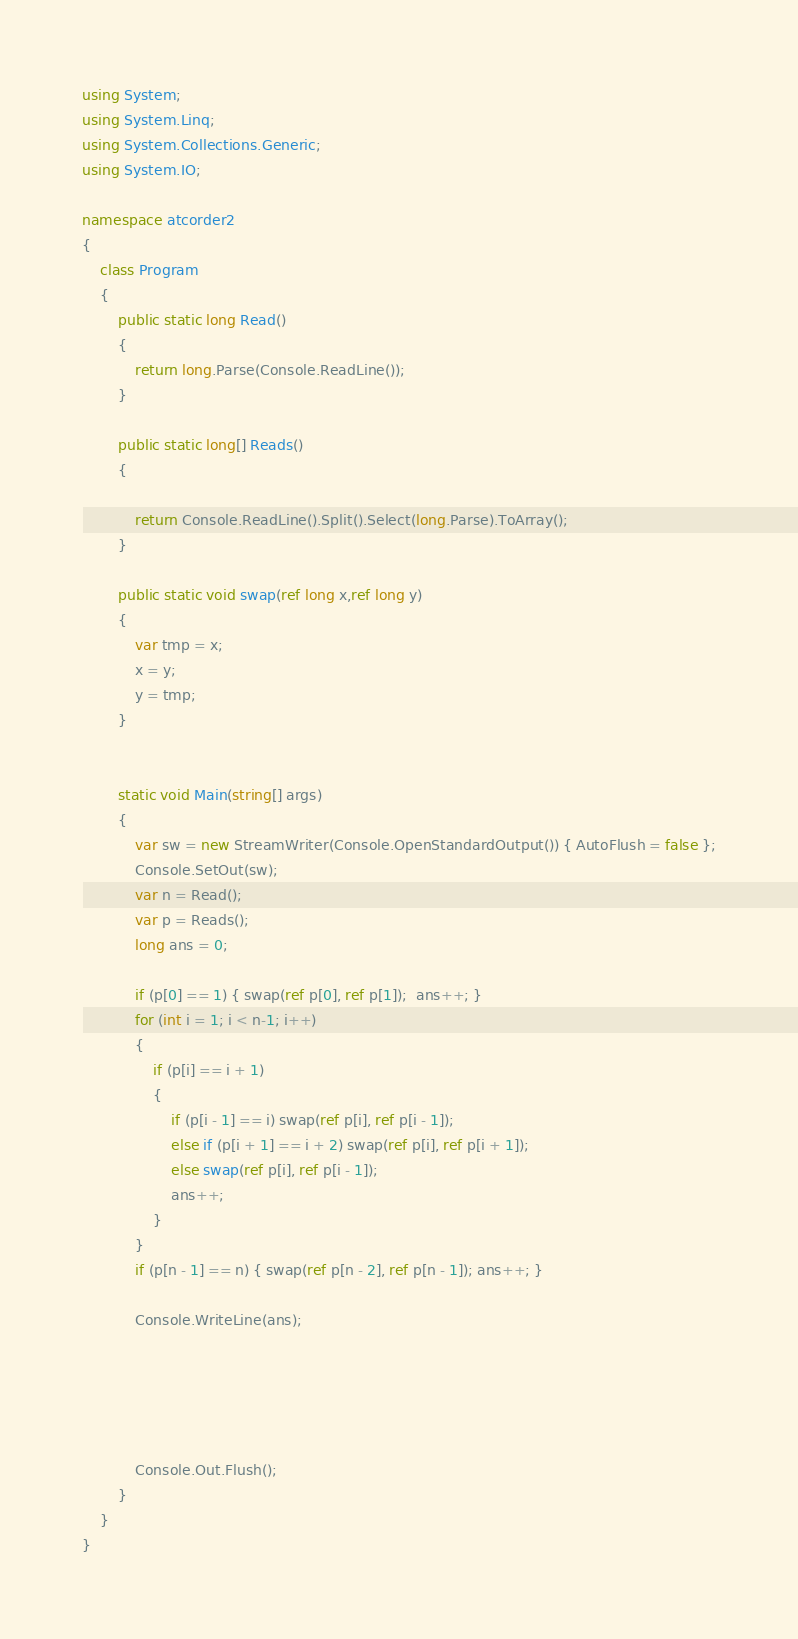<code> <loc_0><loc_0><loc_500><loc_500><_C#_>using System;
using System.Linq;
using System.Collections.Generic;
using System.IO;

namespace atcorder2
{
    class Program
    {
        public static long Read()
        {
            return long.Parse(Console.ReadLine());
        }

        public static long[] Reads()
        {

            return Console.ReadLine().Split().Select(long.Parse).ToArray();
        }

        public static void swap(ref long x,ref long y)
        {
            var tmp = x;
            x = y;
            y = tmp;
        }
        

        static void Main(string[] args)
        {
            var sw = new StreamWriter(Console.OpenStandardOutput()) { AutoFlush = false };
            Console.SetOut(sw);
            var n = Read();
            var p = Reads();
            long ans = 0;

            if (p[0] == 1) { swap(ref p[0], ref p[1]);  ans++; }  
            for (int i = 1; i < n-1; i++)
            {
                if (p[i] == i + 1)
                {
                    if (p[i - 1] == i) swap(ref p[i], ref p[i - 1]);
                    else if (p[i + 1] == i + 2) swap(ref p[i], ref p[i + 1]);
                    else swap(ref p[i], ref p[i - 1]);
                    ans++;
                }
            }
            if (p[n - 1] == n) { swap(ref p[n - 2], ref p[n - 1]); ans++; }

            Console.WriteLine(ans);





            Console.Out.Flush();
        }
    }
}</code> 